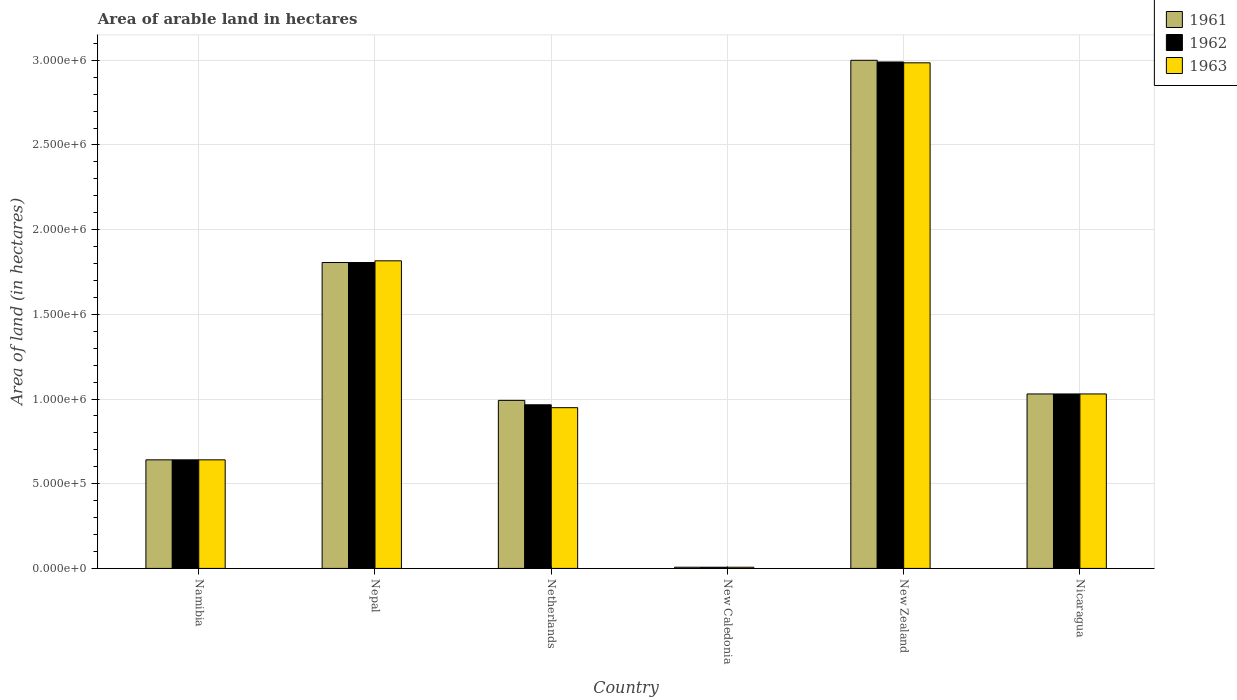How many different coloured bars are there?
Offer a very short reply. 3. How many groups of bars are there?
Your answer should be compact. 6. Are the number of bars per tick equal to the number of legend labels?
Give a very brief answer. Yes. Are the number of bars on each tick of the X-axis equal?
Offer a very short reply. Yes. How many bars are there on the 6th tick from the right?
Offer a terse response. 3. What is the label of the 4th group of bars from the left?
Your answer should be compact. New Caledonia. In how many cases, is the number of bars for a given country not equal to the number of legend labels?
Your answer should be very brief. 0. What is the total arable land in 1962 in Namibia?
Provide a succinct answer. 6.41e+05. Across all countries, what is the maximum total arable land in 1963?
Give a very brief answer. 2.98e+06. Across all countries, what is the minimum total arable land in 1963?
Your answer should be very brief. 7000. In which country was the total arable land in 1962 maximum?
Your answer should be compact. New Zealand. In which country was the total arable land in 1962 minimum?
Offer a terse response. New Caledonia. What is the total total arable land in 1962 in the graph?
Provide a short and direct response. 7.44e+06. What is the difference between the total arable land in 1961 in Namibia and that in Nicaragua?
Your answer should be very brief. -3.89e+05. What is the difference between the total arable land in 1961 in Netherlands and the total arable land in 1962 in Namibia?
Ensure brevity in your answer.  3.51e+05. What is the average total arable land in 1961 per country?
Offer a very short reply. 1.25e+06. What is the difference between the total arable land of/in 1961 and total arable land of/in 1963 in New Zealand?
Your answer should be compact. 1.50e+04. What is the ratio of the total arable land in 1963 in Namibia to that in New Zealand?
Keep it short and to the point. 0.21. Is the total arable land in 1963 in Namibia less than that in Nicaragua?
Give a very brief answer. Yes. Is the difference between the total arable land in 1961 in Netherlands and New Caledonia greater than the difference between the total arable land in 1963 in Netherlands and New Caledonia?
Provide a short and direct response. Yes. What is the difference between the highest and the second highest total arable land in 1963?
Your answer should be very brief. 1.96e+06. What is the difference between the highest and the lowest total arable land in 1961?
Keep it short and to the point. 2.99e+06. Is the sum of the total arable land in 1963 in New Zealand and Nicaragua greater than the maximum total arable land in 1962 across all countries?
Give a very brief answer. Yes. What does the 3rd bar from the left in Nicaragua represents?
Provide a succinct answer. 1963. How many bars are there?
Provide a succinct answer. 18. How many countries are there in the graph?
Provide a short and direct response. 6. What is the difference between two consecutive major ticks on the Y-axis?
Ensure brevity in your answer.  5.00e+05. Are the values on the major ticks of Y-axis written in scientific E-notation?
Your answer should be very brief. Yes. Does the graph contain grids?
Provide a short and direct response. Yes. Where does the legend appear in the graph?
Provide a short and direct response. Top right. What is the title of the graph?
Make the answer very short. Area of arable land in hectares. What is the label or title of the X-axis?
Provide a succinct answer. Country. What is the label or title of the Y-axis?
Make the answer very short. Area of land (in hectares). What is the Area of land (in hectares) of 1961 in Namibia?
Provide a short and direct response. 6.41e+05. What is the Area of land (in hectares) in 1962 in Namibia?
Offer a very short reply. 6.41e+05. What is the Area of land (in hectares) in 1963 in Namibia?
Provide a succinct answer. 6.41e+05. What is the Area of land (in hectares) in 1961 in Nepal?
Offer a terse response. 1.81e+06. What is the Area of land (in hectares) in 1962 in Nepal?
Provide a succinct answer. 1.81e+06. What is the Area of land (in hectares) in 1963 in Nepal?
Give a very brief answer. 1.82e+06. What is the Area of land (in hectares) of 1961 in Netherlands?
Keep it short and to the point. 9.92e+05. What is the Area of land (in hectares) in 1962 in Netherlands?
Provide a succinct answer. 9.66e+05. What is the Area of land (in hectares) of 1963 in Netherlands?
Offer a very short reply. 9.49e+05. What is the Area of land (in hectares) in 1961 in New Caledonia?
Your answer should be very brief. 7000. What is the Area of land (in hectares) in 1962 in New Caledonia?
Give a very brief answer. 7000. What is the Area of land (in hectares) in 1963 in New Caledonia?
Give a very brief answer. 7000. What is the Area of land (in hectares) of 1961 in New Zealand?
Your response must be concise. 3.00e+06. What is the Area of land (in hectares) of 1962 in New Zealand?
Offer a very short reply. 2.99e+06. What is the Area of land (in hectares) of 1963 in New Zealand?
Provide a short and direct response. 2.98e+06. What is the Area of land (in hectares) in 1961 in Nicaragua?
Make the answer very short. 1.03e+06. What is the Area of land (in hectares) in 1962 in Nicaragua?
Your answer should be very brief. 1.03e+06. What is the Area of land (in hectares) in 1963 in Nicaragua?
Offer a terse response. 1.03e+06. Across all countries, what is the maximum Area of land (in hectares) of 1962?
Offer a terse response. 2.99e+06. Across all countries, what is the maximum Area of land (in hectares) of 1963?
Provide a succinct answer. 2.98e+06. Across all countries, what is the minimum Area of land (in hectares) in 1961?
Your answer should be compact. 7000. Across all countries, what is the minimum Area of land (in hectares) in 1962?
Your answer should be very brief. 7000. Across all countries, what is the minimum Area of land (in hectares) of 1963?
Keep it short and to the point. 7000. What is the total Area of land (in hectares) of 1961 in the graph?
Your response must be concise. 7.48e+06. What is the total Area of land (in hectares) of 1962 in the graph?
Keep it short and to the point. 7.44e+06. What is the total Area of land (in hectares) in 1963 in the graph?
Provide a short and direct response. 7.43e+06. What is the difference between the Area of land (in hectares) in 1961 in Namibia and that in Nepal?
Provide a short and direct response. -1.16e+06. What is the difference between the Area of land (in hectares) of 1962 in Namibia and that in Nepal?
Provide a succinct answer. -1.16e+06. What is the difference between the Area of land (in hectares) of 1963 in Namibia and that in Nepal?
Offer a very short reply. -1.18e+06. What is the difference between the Area of land (in hectares) of 1961 in Namibia and that in Netherlands?
Give a very brief answer. -3.51e+05. What is the difference between the Area of land (in hectares) in 1962 in Namibia and that in Netherlands?
Offer a terse response. -3.25e+05. What is the difference between the Area of land (in hectares) of 1963 in Namibia and that in Netherlands?
Offer a terse response. -3.08e+05. What is the difference between the Area of land (in hectares) of 1961 in Namibia and that in New Caledonia?
Give a very brief answer. 6.34e+05. What is the difference between the Area of land (in hectares) in 1962 in Namibia and that in New Caledonia?
Offer a terse response. 6.34e+05. What is the difference between the Area of land (in hectares) of 1963 in Namibia and that in New Caledonia?
Your response must be concise. 6.34e+05. What is the difference between the Area of land (in hectares) in 1961 in Namibia and that in New Zealand?
Provide a short and direct response. -2.36e+06. What is the difference between the Area of land (in hectares) of 1962 in Namibia and that in New Zealand?
Your response must be concise. -2.35e+06. What is the difference between the Area of land (in hectares) in 1963 in Namibia and that in New Zealand?
Offer a very short reply. -2.34e+06. What is the difference between the Area of land (in hectares) in 1961 in Namibia and that in Nicaragua?
Make the answer very short. -3.89e+05. What is the difference between the Area of land (in hectares) in 1962 in Namibia and that in Nicaragua?
Provide a succinct answer. -3.89e+05. What is the difference between the Area of land (in hectares) of 1963 in Namibia and that in Nicaragua?
Offer a terse response. -3.89e+05. What is the difference between the Area of land (in hectares) of 1961 in Nepal and that in Netherlands?
Provide a short and direct response. 8.14e+05. What is the difference between the Area of land (in hectares) of 1962 in Nepal and that in Netherlands?
Your response must be concise. 8.40e+05. What is the difference between the Area of land (in hectares) in 1963 in Nepal and that in Netherlands?
Your answer should be compact. 8.67e+05. What is the difference between the Area of land (in hectares) of 1961 in Nepal and that in New Caledonia?
Provide a short and direct response. 1.80e+06. What is the difference between the Area of land (in hectares) in 1962 in Nepal and that in New Caledonia?
Your answer should be very brief. 1.80e+06. What is the difference between the Area of land (in hectares) of 1963 in Nepal and that in New Caledonia?
Your answer should be very brief. 1.81e+06. What is the difference between the Area of land (in hectares) of 1961 in Nepal and that in New Zealand?
Your answer should be very brief. -1.19e+06. What is the difference between the Area of land (in hectares) in 1962 in Nepal and that in New Zealand?
Ensure brevity in your answer.  -1.18e+06. What is the difference between the Area of land (in hectares) in 1963 in Nepal and that in New Zealand?
Offer a terse response. -1.17e+06. What is the difference between the Area of land (in hectares) in 1961 in Nepal and that in Nicaragua?
Provide a succinct answer. 7.76e+05. What is the difference between the Area of land (in hectares) of 1962 in Nepal and that in Nicaragua?
Your answer should be very brief. 7.76e+05. What is the difference between the Area of land (in hectares) in 1963 in Nepal and that in Nicaragua?
Offer a terse response. 7.86e+05. What is the difference between the Area of land (in hectares) of 1961 in Netherlands and that in New Caledonia?
Your response must be concise. 9.85e+05. What is the difference between the Area of land (in hectares) of 1962 in Netherlands and that in New Caledonia?
Provide a succinct answer. 9.59e+05. What is the difference between the Area of land (in hectares) of 1963 in Netherlands and that in New Caledonia?
Keep it short and to the point. 9.42e+05. What is the difference between the Area of land (in hectares) in 1961 in Netherlands and that in New Zealand?
Your answer should be compact. -2.01e+06. What is the difference between the Area of land (in hectares) of 1962 in Netherlands and that in New Zealand?
Your response must be concise. -2.02e+06. What is the difference between the Area of land (in hectares) of 1963 in Netherlands and that in New Zealand?
Your response must be concise. -2.04e+06. What is the difference between the Area of land (in hectares) of 1961 in Netherlands and that in Nicaragua?
Make the answer very short. -3.80e+04. What is the difference between the Area of land (in hectares) of 1962 in Netherlands and that in Nicaragua?
Offer a terse response. -6.40e+04. What is the difference between the Area of land (in hectares) of 1963 in Netherlands and that in Nicaragua?
Your answer should be compact. -8.10e+04. What is the difference between the Area of land (in hectares) in 1961 in New Caledonia and that in New Zealand?
Your answer should be compact. -2.99e+06. What is the difference between the Area of land (in hectares) of 1962 in New Caledonia and that in New Zealand?
Your answer should be very brief. -2.98e+06. What is the difference between the Area of land (in hectares) of 1963 in New Caledonia and that in New Zealand?
Make the answer very short. -2.98e+06. What is the difference between the Area of land (in hectares) in 1961 in New Caledonia and that in Nicaragua?
Keep it short and to the point. -1.02e+06. What is the difference between the Area of land (in hectares) in 1962 in New Caledonia and that in Nicaragua?
Your answer should be very brief. -1.02e+06. What is the difference between the Area of land (in hectares) in 1963 in New Caledonia and that in Nicaragua?
Your answer should be very brief. -1.02e+06. What is the difference between the Area of land (in hectares) of 1961 in New Zealand and that in Nicaragua?
Provide a succinct answer. 1.97e+06. What is the difference between the Area of land (in hectares) in 1962 in New Zealand and that in Nicaragua?
Keep it short and to the point. 1.96e+06. What is the difference between the Area of land (in hectares) in 1963 in New Zealand and that in Nicaragua?
Offer a terse response. 1.96e+06. What is the difference between the Area of land (in hectares) in 1961 in Namibia and the Area of land (in hectares) in 1962 in Nepal?
Keep it short and to the point. -1.16e+06. What is the difference between the Area of land (in hectares) of 1961 in Namibia and the Area of land (in hectares) of 1963 in Nepal?
Offer a terse response. -1.18e+06. What is the difference between the Area of land (in hectares) in 1962 in Namibia and the Area of land (in hectares) in 1963 in Nepal?
Ensure brevity in your answer.  -1.18e+06. What is the difference between the Area of land (in hectares) in 1961 in Namibia and the Area of land (in hectares) in 1962 in Netherlands?
Make the answer very short. -3.25e+05. What is the difference between the Area of land (in hectares) of 1961 in Namibia and the Area of land (in hectares) of 1963 in Netherlands?
Your response must be concise. -3.08e+05. What is the difference between the Area of land (in hectares) in 1962 in Namibia and the Area of land (in hectares) in 1963 in Netherlands?
Your answer should be compact. -3.08e+05. What is the difference between the Area of land (in hectares) of 1961 in Namibia and the Area of land (in hectares) of 1962 in New Caledonia?
Your answer should be very brief. 6.34e+05. What is the difference between the Area of land (in hectares) in 1961 in Namibia and the Area of land (in hectares) in 1963 in New Caledonia?
Make the answer very short. 6.34e+05. What is the difference between the Area of land (in hectares) in 1962 in Namibia and the Area of land (in hectares) in 1963 in New Caledonia?
Your response must be concise. 6.34e+05. What is the difference between the Area of land (in hectares) of 1961 in Namibia and the Area of land (in hectares) of 1962 in New Zealand?
Your answer should be very brief. -2.35e+06. What is the difference between the Area of land (in hectares) in 1961 in Namibia and the Area of land (in hectares) in 1963 in New Zealand?
Keep it short and to the point. -2.34e+06. What is the difference between the Area of land (in hectares) of 1962 in Namibia and the Area of land (in hectares) of 1963 in New Zealand?
Offer a terse response. -2.34e+06. What is the difference between the Area of land (in hectares) in 1961 in Namibia and the Area of land (in hectares) in 1962 in Nicaragua?
Make the answer very short. -3.89e+05. What is the difference between the Area of land (in hectares) of 1961 in Namibia and the Area of land (in hectares) of 1963 in Nicaragua?
Your answer should be very brief. -3.89e+05. What is the difference between the Area of land (in hectares) in 1962 in Namibia and the Area of land (in hectares) in 1963 in Nicaragua?
Provide a succinct answer. -3.89e+05. What is the difference between the Area of land (in hectares) of 1961 in Nepal and the Area of land (in hectares) of 1962 in Netherlands?
Keep it short and to the point. 8.40e+05. What is the difference between the Area of land (in hectares) of 1961 in Nepal and the Area of land (in hectares) of 1963 in Netherlands?
Provide a succinct answer. 8.57e+05. What is the difference between the Area of land (in hectares) of 1962 in Nepal and the Area of land (in hectares) of 1963 in Netherlands?
Keep it short and to the point. 8.57e+05. What is the difference between the Area of land (in hectares) of 1961 in Nepal and the Area of land (in hectares) of 1962 in New Caledonia?
Your answer should be compact. 1.80e+06. What is the difference between the Area of land (in hectares) of 1961 in Nepal and the Area of land (in hectares) of 1963 in New Caledonia?
Provide a short and direct response. 1.80e+06. What is the difference between the Area of land (in hectares) of 1962 in Nepal and the Area of land (in hectares) of 1963 in New Caledonia?
Your answer should be very brief. 1.80e+06. What is the difference between the Area of land (in hectares) in 1961 in Nepal and the Area of land (in hectares) in 1962 in New Zealand?
Offer a very short reply. -1.18e+06. What is the difference between the Area of land (in hectares) in 1961 in Nepal and the Area of land (in hectares) in 1963 in New Zealand?
Provide a short and direct response. -1.18e+06. What is the difference between the Area of land (in hectares) in 1962 in Nepal and the Area of land (in hectares) in 1963 in New Zealand?
Provide a succinct answer. -1.18e+06. What is the difference between the Area of land (in hectares) in 1961 in Nepal and the Area of land (in hectares) in 1962 in Nicaragua?
Your answer should be compact. 7.76e+05. What is the difference between the Area of land (in hectares) of 1961 in Nepal and the Area of land (in hectares) of 1963 in Nicaragua?
Offer a terse response. 7.76e+05. What is the difference between the Area of land (in hectares) of 1962 in Nepal and the Area of land (in hectares) of 1963 in Nicaragua?
Your answer should be compact. 7.76e+05. What is the difference between the Area of land (in hectares) in 1961 in Netherlands and the Area of land (in hectares) in 1962 in New Caledonia?
Provide a succinct answer. 9.85e+05. What is the difference between the Area of land (in hectares) of 1961 in Netherlands and the Area of land (in hectares) of 1963 in New Caledonia?
Keep it short and to the point. 9.85e+05. What is the difference between the Area of land (in hectares) of 1962 in Netherlands and the Area of land (in hectares) of 1963 in New Caledonia?
Keep it short and to the point. 9.59e+05. What is the difference between the Area of land (in hectares) of 1961 in Netherlands and the Area of land (in hectares) of 1962 in New Zealand?
Offer a terse response. -2.00e+06. What is the difference between the Area of land (in hectares) of 1961 in Netherlands and the Area of land (in hectares) of 1963 in New Zealand?
Ensure brevity in your answer.  -1.99e+06. What is the difference between the Area of land (in hectares) in 1962 in Netherlands and the Area of land (in hectares) in 1963 in New Zealand?
Give a very brief answer. -2.02e+06. What is the difference between the Area of land (in hectares) of 1961 in Netherlands and the Area of land (in hectares) of 1962 in Nicaragua?
Offer a terse response. -3.80e+04. What is the difference between the Area of land (in hectares) in 1961 in Netherlands and the Area of land (in hectares) in 1963 in Nicaragua?
Your response must be concise. -3.80e+04. What is the difference between the Area of land (in hectares) in 1962 in Netherlands and the Area of land (in hectares) in 1963 in Nicaragua?
Provide a succinct answer. -6.40e+04. What is the difference between the Area of land (in hectares) in 1961 in New Caledonia and the Area of land (in hectares) in 1962 in New Zealand?
Provide a short and direct response. -2.98e+06. What is the difference between the Area of land (in hectares) in 1961 in New Caledonia and the Area of land (in hectares) in 1963 in New Zealand?
Offer a terse response. -2.98e+06. What is the difference between the Area of land (in hectares) in 1962 in New Caledonia and the Area of land (in hectares) in 1963 in New Zealand?
Offer a very short reply. -2.98e+06. What is the difference between the Area of land (in hectares) in 1961 in New Caledonia and the Area of land (in hectares) in 1962 in Nicaragua?
Keep it short and to the point. -1.02e+06. What is the difference between the Area of land (in hectares) of 1961 in New Caledonia and the Area of land (in hectares) of 1963 in Nicaragua?
Provide a succinct answer. -1.02e+06. What is the difference between the Area of land (in hectares) in 1962 in New Caledonia and the Area of land (in hectares) in 1963 in Nicaragua?
Offer a terse response. -1.02e+06. What is the difference between the Area of land (in hectares) in 1961 in New Zealand and the Area of land (in hectares) in 1962 in Nicaragua?
Offer a terse response. 1.97e+06. What is the difference between the Area of land (in hectares) of 1961 in New Zealand and the Area of land (in hectares) of 1963 in Nicaragua?
Keep it short and to the point. 1.97e+06. What is the difference between the Area of land (in hectares) in 1962 in New Zealand and the Area of land (in hectares) in 1963 in Nicaragua?
Keep it short and to the point. 1.96e+06. What is the average Area of land (in hectares) of 1961 per country?
Provide a succinct answer. 1.25e+06. What is the average Area of land (in hectares) of 1962 per country?
Provide a short and direct response. 1.24e+06. What is the average Area of land (in hectares) in 1963 per country?
Keep it short and to the point. 1.24e+06. What is the difference between the Area of land (in hectares) of 1961 and Area of land (in hectares) of 1963 in Namibia?
Keep it short and to the point. 0. What is the difference between the Area of land (in hectares) in 1962 and Area of land (in hectares) in 1963 in Namibia?
Your answer should be compact. 0. What is the difference between the Area of land (in hectares) in 1961 and Area of land (in hectares) in 1963 in Nepal?
Give a very brief answer. -10000. What is the difference between the Area of land (in hectares) of 1961 and Area of land (in hectares) of 1962 in Netherlands?
Give a very brief answer. 2.60e+04. What is the difference between the Area of land (in hectares) in 1961 and Area of land (in hectares) in 1963 in Netherlands?
Provide a short and direct response. 4.30e+04. What is the difference between the Area of land (in hectares) in 1962 and Area of land (in hectares) in 1963 in Netherlands?
Provide a short and direct response. 1.70e+04. What is the difference between the Area of land (in hectares) in 1961 and Area of land (in hectares) in 1962 in New Caledonia?
Offer a very short reply. 0. What is the difference between the Area of land (in hectares) of 1961 and Area of land (in hectares) of 1963 in New Zealand?
Make the answer very short. 1.50e+04. What is the difference between the Area of land (in hectares) in 1962 and Area of land (in hectares) in 1963 in New Zealand?
Your answer should be very brief. 5000. What is the difference between the Area of land (in hectares) of 1961 and Area of land (in hectares) of 1963 in Nicaragua?
Provide a succinct answer. 0. What is the difference between the Area of land (in hectares) in 1962 and Area of land (in hectares) in 1963 in Nicaragua?
Your response must be concise. 0. What is the ratio of the Area of land (in hectares) of 1961 in Namibia to that in Nepal?
Give a very brief answer. 0.35. What is the ratio of the Area of land (in hectares) of 1962 in Namibia to that in Nepal?
Make the answer very short. 0.35. What is the ratio of the Area of land (in hectares) in 1963 in Namibia to that in Nepal?
Your answer should be very brief. 0.35. What is the ratio of the Area of land (in hectares) in 1961 in Namibia to that in Netherlands?
Ensure brevity in your answer.  0.65. What is the ratio of the Area of land (in hectares) of 1962 in Namibia to that in Netherlands?
Your answer should be compact. 0.66. What is the ratio of the Area of land (in hectares) of 1963 in Namibia to that in Netherlands?
Give a very brief answer. 0.68. What is the ratio of the Area of land (in hectares) of 1961 in Namibia to that in New Caledonia?
Provide a succinct answer. 91.57. What is the ratio of the Area of land (in hectares) in 1962 in Namibia to that in New Caledonia?
Offer a terse response. 91.57. What is the ratio of the Area of land (in hectares) of 1963 in Namibia to that in New Caledonia?
Give a very brief answer. 91.57. What is the ratio of the Area of land (in hectares) of 1961 in Namibia to that in New Zealand?
Give a very brief answer. 0.21. What is the ratio of the Area of land (in hectares) in 1962 in Namibia to that in New Zealand?
Offer a terse response. 0.21. What is the ratio of the Area of land (in hectares) in 1963 in Namibia to that in New Zealand?
Ensure brevity in your answer.  0.21. What is the ratio of the Area of land (in hectares) of 1961 in Namibia to that in Nicaragua?
Your response must be concise. 0.62. What is the ratio of the Area of land (in hectares) of 1962 in Namibia to that in Nicaragua?
Provide a short and direct response. 0.62. What is the ratio of the Area of land (in hectares) of 1963 in Namibia to that in Nicaragua?
Make the answer very short. 0.62. What is the ratio of the Area of land (in hectares) of 1961 in Nepal to that in Netherlands?
Your answer should be compact. 1.82. What is the ratio of the Area of land (in hectares) of 1962 in Nepal to that in Netherlands?
Keep it short and to the point. 1.87. What is the ratio of the Area of land (in hectares) in 1963 in Nepal to that in Netherlands?
Offer a terse response. 1.91. What is the ratio of the Area of land (in hectares) of 1961 in Nepal to that in New Caledonia?
Provide a succinct answer. 258. What is the ratio of the Area of land (in hectares) of 1962 in Nepal to that in New Caledonia?
Provide a succinct answer. 258. What is the ratio of the Area of land (in hectares) of 1963 in Nepal to that in New Caledonia?
Offer a terse response. 259.43. What is the ratio of the Area of land (in hectares) in 1961 in Nepal to that in New Zealand?
Keep it short and to the point. 0.6. What is the ratio of the Area of land (in hectares) in 1962 in Nepal to that in New Zealand?
Make the answer very short. 0.6. What is the ratio of the Area of land (in hectares) of 1963 in Nepal to that in New Zealand?
Offer a very short reply. 0.61. What is the ratio of the Area of land (in hectares) of 1961 in Nepal to that in Nicaragua?
Your answer should be compact. 1.75. What is the ratio of the Area of land (in hectares) of 1962 in Nepal to that in Nicaragua?
Your response must be concise. 1.75. What is the ratio of the Area of land (in hectares) in 1963 in Nepal to that in Nicaragua?
Provide a short and direct response. 1.76. What is the ratio of the Area of land (in hectares) in 1961 in Netherlands to that in New Caledonia?
Your answer should be compact. 141.71. What is the ratio of the Area of land (in hectares) of 1962 in Netherlands to that in New Caledonia?
Give a very brief answer. 138. What is the ratio of the Area of land (in hectares) in 1963 in Netherlands to that in New Caledonia?
Ensure brevity in your answer.  135.57. What is the ratio of the Area of land (in hectares) of 1961 in Netherlands to that in New Zealand?
Your answer should be compact. 0.33. What is the ratio of the Area of land (in hectares) of 1962 in Netherlands to that in New Zealand?
Offer a terse response. 0.32. What is the ratio of the Area of land (in hectares) of 1963 in Netherlands to that in New Zealand?
Provide a short and direct response. 0.32. What is the ratio of the Area of land (in hectares) in 1961 in Netherlands to that in Nicaragua?
Make the answer very short. 0.96. What is the ratio of the Area of land (in hectares) in 1962 in Netherlands to that in Nicaragua?
Make the answer very short. 0.94. What is the ratio of the Area of land (in hectares) in 1963 in Netherlands to that in Nicaragua?
Provide a succinct answer. 0.92. What is the ratio of the Area of land (in hectares) in 1961 in New Caledonia to that in New Zealand?
Your answer should be compact. 0. What is the ratio of the Area of land (in hectares) in 1962 in New Caledonia to that in New Zealand?
Provide a short and direct response. 0. What is the ratio of the Area of land (in hectares) of 1963 in New Caledonia to that in New Zealand?
Your response must be concise. 0. What is the ratio of the Area of land (in hectares) in 1961 in New Caledonia to that in Nicaragua?
Provide a short and direct response. 0.01. What is the ratio of the Area of land (in hectares) of 1962 in New Caledonia to that in Nicaragua?
Give a very brief answer. 0.01. What is the ratio of the Area of land (in hectares) in 1963 in New Caledonia to that in Nicaragua?
Make the answer very short. 0.01. What is the ratio of the Area of land (in hectares) of 1961 in New Zealand to that in Nicaragua?
Your answer should be very brief. 2.91. What is the ratio of the Area of land (in hectares) of 1962 in New Zealand to that in Nicaragua?
Provide a short and direct response. 2.9. What is the ratio of the Area of land (in hectares) of 1963 in New Zealand to that in Nicaragua?
Your answer should be compact. 2.9. What is the difference between the highest and the second highest Area of land (in hectares) of 1961?
Make the answer very short. 1.19e+06. What is the difference between the highest and the second highest Area of land (in hectares) in 1962?
Keep it short and to the point. 1.18e+06. What is the difference between the highest and the second highest Area of land (in hectares) of 1963?
Your answer should be very brief. 1.17e+06. What is the difference between the highest and the lowest Area of land (in hectares) of 1961?
Ensure brevity in your answer.  2.99e+06. What is the difference between the highest and the lowest Area of land (in hectares) of 1962?
Make the answer very short. 2.98e+06. What is the difference between the highest and the lowest Area of land (in hectares) in 1963?
Provide a short and direct response. 2.98e+06. 